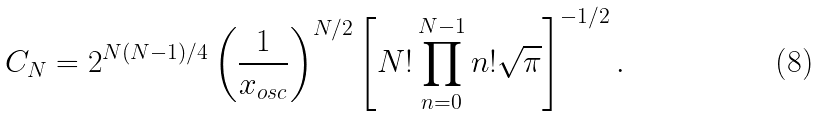<formula> <loc_0><loc_0><loc_500><loc_500>C _ { N } = 2 ^ { N ( N - 1 ) / 4 } \left ( \frac { 1 } { x _ { o s c } } \right ) ^ { N / 2 } \left [ N ! \prod _ { n = 0 } ^ { N - 1 } n ! \sqrt { \pi } \right ] ^ { - 1 / 2 } .</formula> 